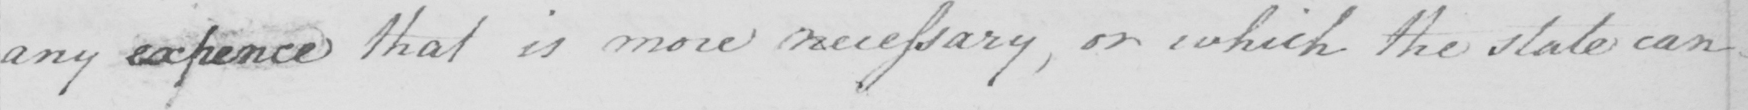Transcribe the text shown in this historical manuscript line. any expence that is more necessary , or which the state can 